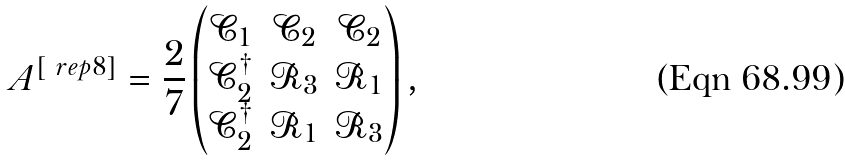<formula> <loc_0><loc_0><loc_500><loc_500>A ^ { [ \ r e p { 8 } ] } = \frac { 2 } { 7 } \begin{pmatrix} \mathcal { C } _ { 1 } & \mathcal { C } _ { 2 } & \mathcal { C } _ { 2 } \\ \mathcal { C } _ { 2 } ^ { \dagger } & \mathcal { R } _ { 3 } & \mathcal { R } _ { 1 } \\ \mathcal { C } _ { 2 } ^ { \dagger } & \mathcal { R } _ { 1 } & \mathcal { R } _ { 3 } \end{pmatrix} ,</formula> 